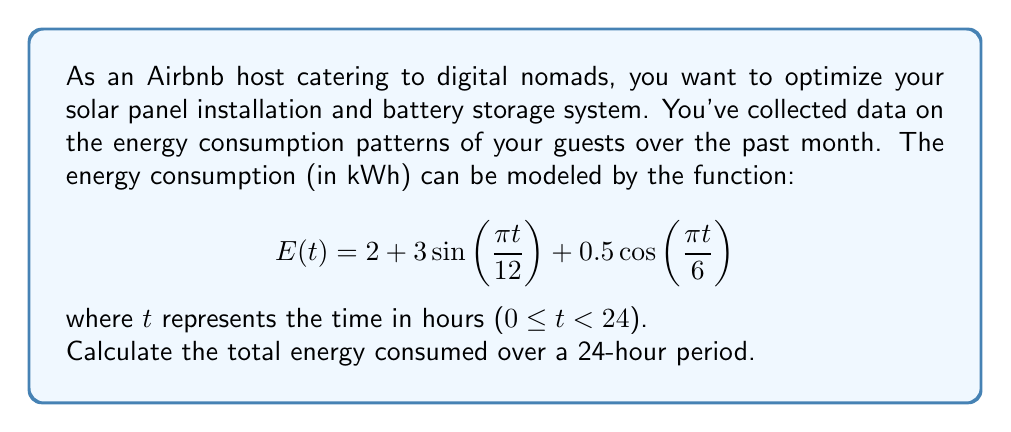What is the answer to this math problem? To find the total energy consumed over a 24-hour period, we need to integrate the energy consumption function E(t) from t = 0 to t = 24.

$$\text{Total Energy} = \int_0^{24} E(t) dt = \int_0^{24} (2 + 3\sin(\frac{\pi t}{12}) + 0.5\cos(\frac{\pi t}{6})) dt$$

Let's break this integral into three parts:

1. $\int_0^{24} 2 dt = 2t \Big|_0^{24} = 2(24) - 2(0) = 48$

2. $\int_0^{24} 3\sin(\frac{\pi t}{12}) dt = -\frac{36}{\pi}\cos(\frac{\pi t}{12}) \Big|_0^{24} = -\frac{36}{\pi}[\cos(2\pi) - \cos(0)] = 0$

3. $\int_0^{24} 0.5\cos(\frac{\pi t}{6}) dt = 0.5 \cdot \frac{6}{\pi}\sin(\frac{\pi t}{6}) \Big|_0^{24} = \frac{3}{\pi}[\sin(4\pi) - \sin(0)] = 0$

The sum of these three integrals gives us the total energy consumed over 24 hours.
Answer: The total energy consumed over a 24-hour period is 48 kWh. 